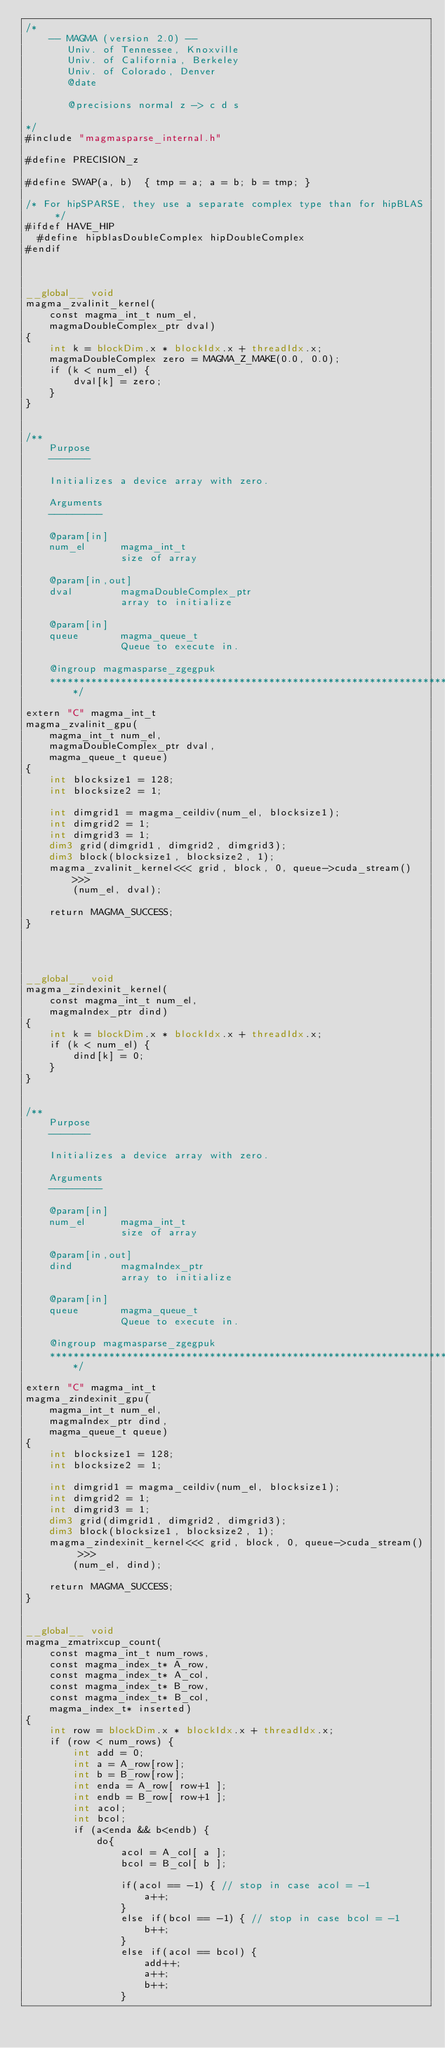Convert code to text. <code><loc_0><loc_0><loc_500><loc_500><_Cuda_>/*
    -- MAGMA (version 2.0) --
       Univ. of Tennessee, Knoxville
       Univ. of California, Berkeley
       Univ. of Colorado, Denver
       @date

       @precisions normal z -> c d s

*/
#include "magmasparse_internal.h"

#define PRECISION_z

#define SWAP(a, b)  { tmp = a; a = b; b = tmp; }

/* For hipSPARSE, they use a separate complex type than for hipBLAS */
#ifdef HAVE_HIP
  #define hipblasDoubleComplex hipDoubleComplex
#endif



__global__ void 
magma_zvalinit_kernel(  
    const magma_int_t num_el, 
    magmaDoubleComplex_ptr dval) 
{
    int k = blockDim.x * blockIdx.x + threadIdx.x;
    magmaDoubleComplex zero = MAGMA_Z_MAKE(0.0, 0.0);
    if (k < num_el) {
        dval[k] = zero;
    }
}


/**
    Purpose
    -------
    
    Initializes a device array with zero. 

    Arguments
    ---------

    @param[in]
    num_el      magma_int_t
                size of array

    @param[in,out]
    dval        magmaDoubleComplex_ptr
                array to initialize
                
    @param[in]
    queue       magma_queue_t
                Queue to execute in.
                
    @ingroup magmasparse_zgegpuk
    ********************************************************************/

extern "C" magma_int_t
magma_zvalinit_gpu(
    magma_int_t num_el,
    magmaDoubleComplex_ptr dval,
    magma_queue_t queue)
{
    int blocksize1 = 128;
    int blocksize2 = 1;

    int dimgrid1 = magma_ceildiv(num_el, blocksize1);
    int dimgrid2 = 1;
    int dimgrid3 = 1;
    dim3 grid(dimgrid1, dimgrid2, dimgrid3);
    dim3 block(blocksize1, blocksize2, 1);
    magma_zvalinit_kernel<<< grid, block, 0, queue->cuda_stream() >>>
        (num_el, dval);

    return MAGMA_SUCCESS;
}




__global__ void 
magma_zindexinit_kernel(  
    const magma_int_t num_el, 
    magmaIndex_ptr dind) 
{
    int k = blockDim.x * blockIdx.x + threadIdx.x;
    if (k < num_el) {
        dind[k] = 0;
    }
}


/**
    Purpose
    -------
    
    Initializes a device array with zero. 

    Arguments
    ---------

    @param[in]
    num_el      magma_int_t
                size of array

    @param[in,out]
    dind        magmaIndex_ptr
                array to initialize
                
    @param[in]
    queue       magma_queue_t
                Queue to execute in.
                
    @ingroup magmasparse_zgegpuk
    ********************************************************************/

extern "C" magma_int_t
magma_zindexinit_gpu(
    magma_int_t num_el,
    magmaIndex_ptr dind,
    magma_queue_t queue)
{
    int blocksize1 = 128;
    int blocksize2 = 1;

    int dimgrid1 = magma_ceildiv(num_el, blocksize1);
    int dimgrid2 = 1;
    int dimgrid3 = 1;
    dim3 grid(dimgrid1, dimgrid2, dimgrid3);
    dim3 block(blocksize1, blocksize2, 1);
    magma_zindexinit_kernel<<< grid, block, 0, queue->cuda_stream() >>>
        (num_el, dind);

    return MAGMA_SUCCESS;
}


__global__ void 
magma_zmatrixcup_count(  
    const magma_int_t num_rows,
    const magma_index_t* A_row,
    const magma_index_t* A_col,
    const magma_index_t* B_row,
    const magma_index_t* B_col,
    magma_index_t* inserted)
{
    int row = blockDim.x * blockIdx.x + threadIdx.x;
    if (row < num_rows) {
        int add = 0;
        int a = A_row[row];
        int b = B_row[row];
        int enda = A_row[ row+1 ];
        int endb = B_row[ row+1 ]; 
        int acol;
        int bcol;
        if (a<enda && b<endb) {
            do{
                acol = A_col[ a ];
                bcol = B_col[ b ];
                
                if(acol == -1) { // stop in case acol = -1
                    a++;
                } 
                else if(bcol == -1) { // stop in case bcol = -1
                    b++;
                }
                else if(acol == bcol) {
                    add++;
                    a++;
                    b++;
                }</code> 